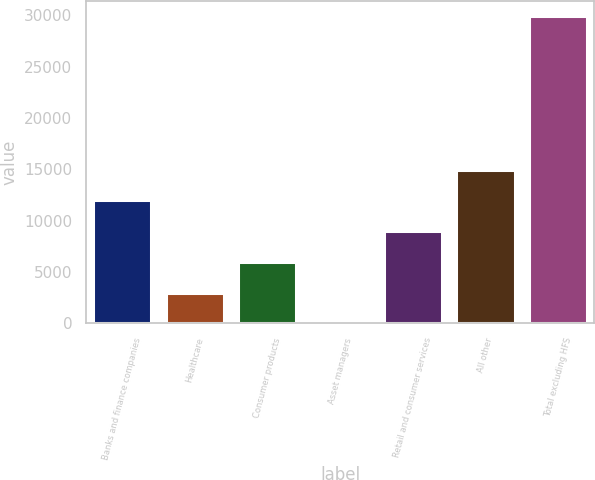Convert chart to OTSL. <chart><loc_0><loc_0><loc_500><loc_500><bar_chart><fcel>Banks and finance companies<fcel>Healthcare<fcel>Consumer products<fcel>Asset managers<fcel>Retail and consumer services<fcel>All other<fcel>Total excluding HFS<nl><fcel>11967.8<fcel>3010.7<fcel>5996.4<fcel>25<fcel>8982.1<fcel>14953.5<fcel>29882<nl></chart> 